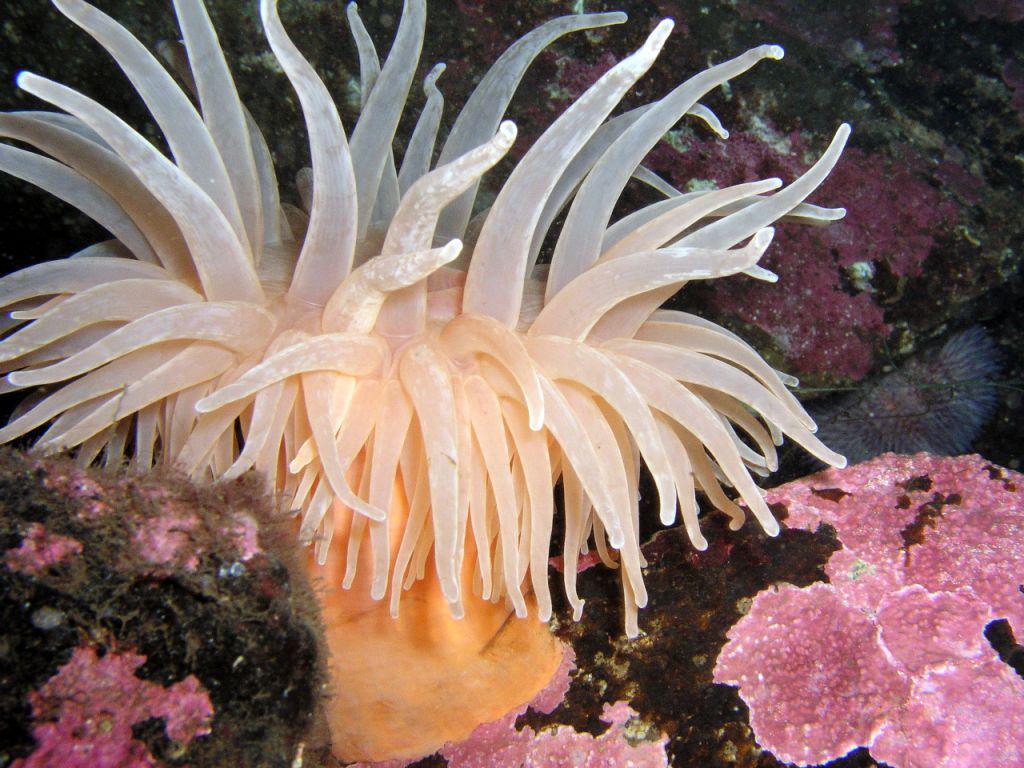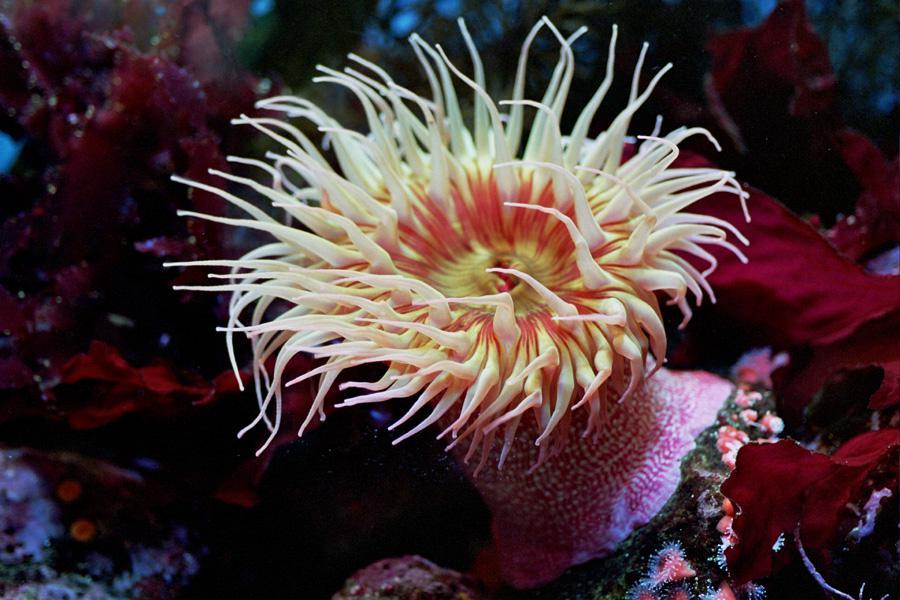The first image is the image on the left, the second image is the image on the right. Assess this claim about the two images: "The trunk of the anemone can be seen in the image on the left.". Correct or not? Answer yes or no. Yes. The first image is the image on the left, the second image is the image on the right. Assess this claim about the two images: "The left image shows a white anemone with its mouth-like center visible.". Correct or not? Answer yes or no. No. 